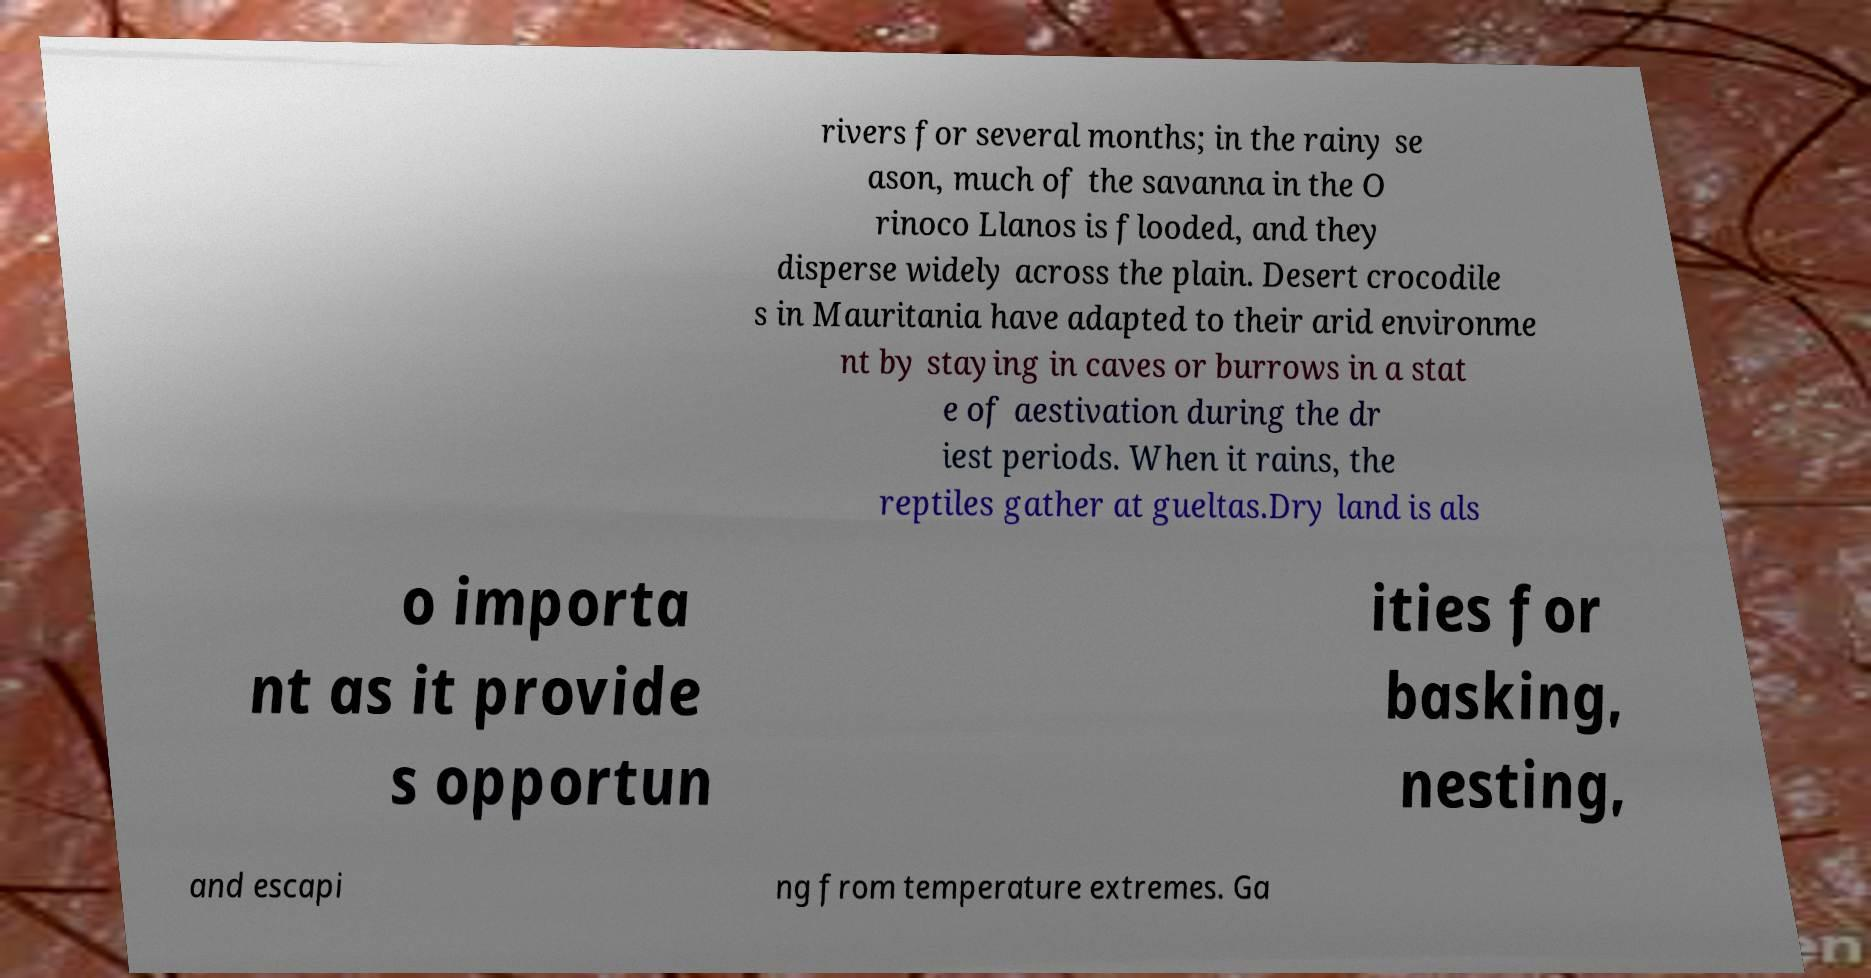Could you assist in decoding the text presented in this image and type it out clearly? rivers for several months; in the rainy se ason, much of the savanna in the O rinoco Llanos is flooded, and they disperse widely across the plain. Desert crocodile s in Mauritania have adapted to their arid environme nt by staying in caves or burrows in a stat e of aestivation during the dr iest periods. When it rains, the reptiles gather at gueltas.Dry land is als o importa nt as it provide s opportun ities for basking, nesting, and escapi ng from temperature extremes. Ga 